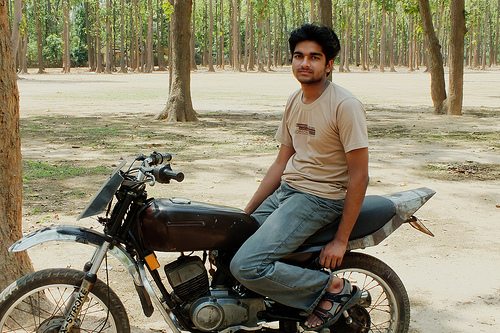<image>
Is the bike under the tree? No. The bike is not positioned under the tree. The vertical relationship between these objects is different. Is the rider behind the bike? No. The rider is not behind the bike. From this viewpoint, the rider appears to be positioned elsewhere in the scene. 